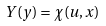<formula> <loc_0><loc_0><loc_500><loc_500>Y ( y ) = \chi ( u , x )</formula> 